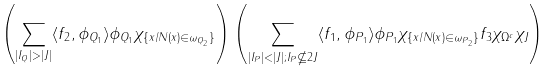Convert formula to latex. <formula><loc_0><loc_0><loc_500><loc_500>\left ( \sum _ { | I _ { Q } | > | J | } \langle f _ { 2 } , \phi _ { Q _ { 1 } } \rangle \phi _ { Q _ { 1 } } \chi _ { \{ x / N ( x ) \in \omega _ { Q _ { 2 } } \} } \right ) \left ( \sum _ { | I _ { P } | < | J | ; I _ { P } \nsubseteq 2 J } \langle f _ { 1 } , \phi _ { P _ { 1 } } \rangle \phi _ { P _ { 1 } } \chi _ { \{ x / N ( x ) \in \omega _ { P _ { 2 } } \} } f _ { 3 } \chi _ { \Omega ^ { c } } \chi _ { J } \right )</formula> 